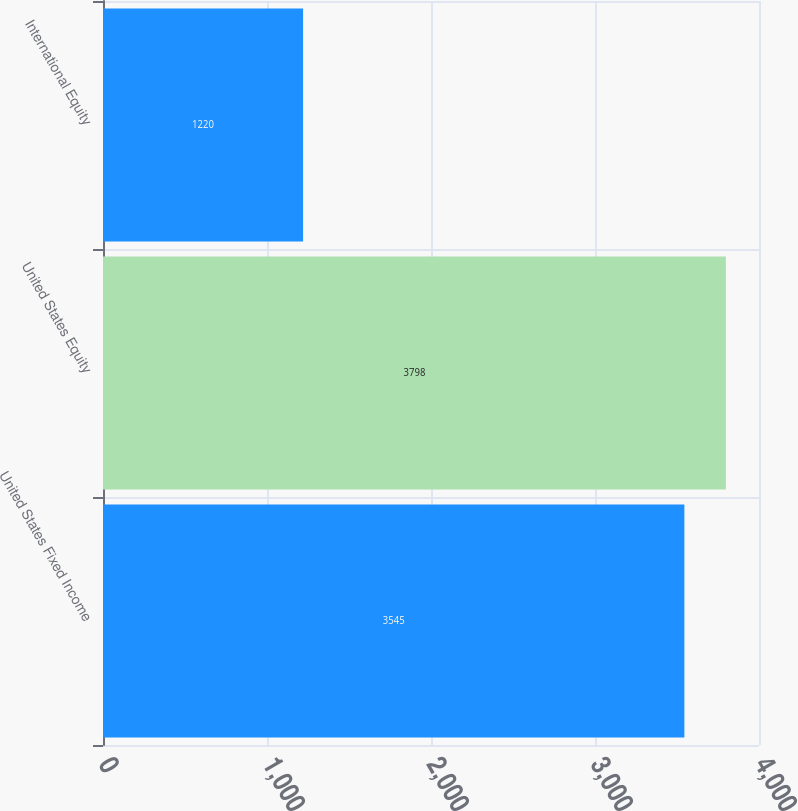<chart> <loc_0><loc_0><loc_500><loc_500><bar_chart><fcel>United States Fixed Income<fcel>United States Equity<fcel>International Equity<nl><fcel>3545<fcel>3798<fcel>1220<nl></chart> 